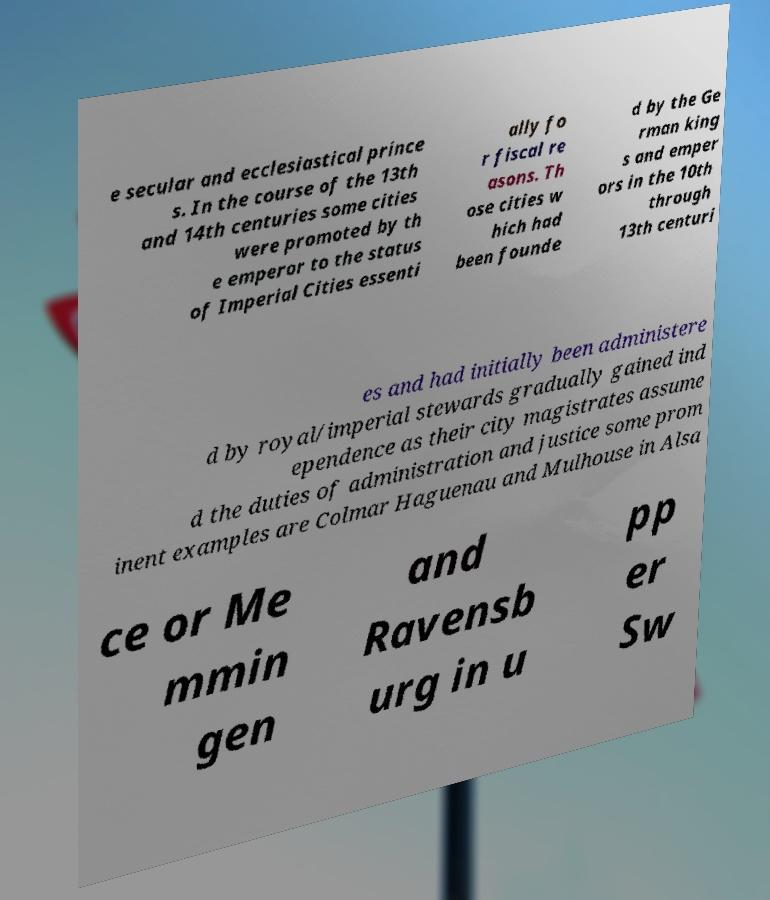Could you extract and type out the text from this image? e secular and ecclesiastical prince s. In the course of the 13th and 14th centuries some cities were promoted by th e emperor to the status of Imperial Cities essenti ally fo r fiscal re asons. Th ose cities w hich had been founde d by the Ge rman king s and emper ors in the 10th through 13th centuri es and had initially been administere d by royal/imperial stewards gradually gained ind ependence as their city magistrates assume d the duties of administration and justice some prom inent examples are Colmar Haguenau and Mulhouse in Alsa ce or Me mmin gen and Ravensb urg in u pp er Sw 